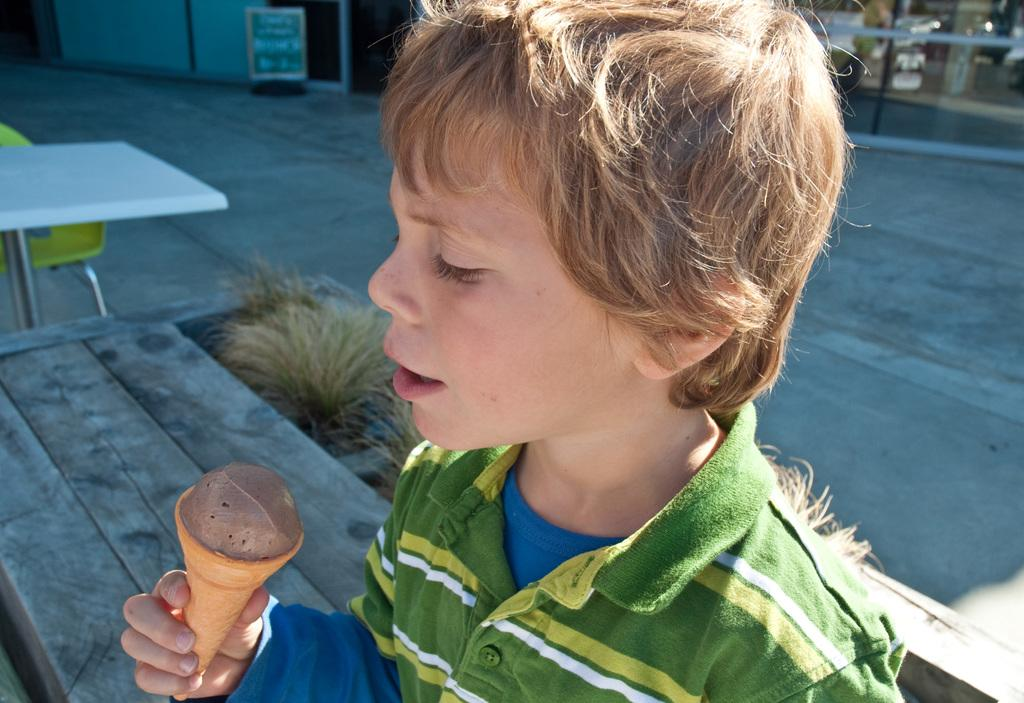What is the main subject in the foreground of the image? There is a boy in the foreground of the image. What is the boy holding in the image? The boy is holding an ice cream. Where is the boy sitting in the image? The boy is sitting on a bench. What type of surface is visible in the image? There is grass, a table, a chair, a floor, and a wall visible in the image. Can you see a worm crawling on the boy's ice cream in the image? No, there is no worm present in the image. 